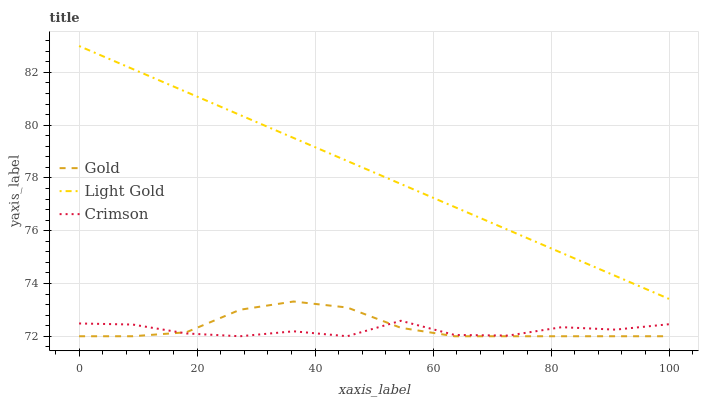Does Crimson have the minimum area under the curve?
Answer yes or no. Yes. Does Light Gold have the maximum area under the curve?
Answer yes or no. Yes. Does Gold have the minimum area under the curve?
Answer yes or no. No. Does Gold have the maximum area under the curve?
Answer yes or no. No. Is Light Gold the smoothest?
Answer yes or no. Yes. Is Crimson the roughest?
Answer yes or no. Yes. Is Gold the smoothest?
Answer yes or no. No. Is Gold the roughest?
Answer yes or no. No. Does Crimson have the lowest value?
Answer yes or no. Yes. Does Light Gold have the lowest value?
Answer yes or no. No. Does Light Gold have the highest value?
Answer yes or no. Yes. Does Gold have the highest value?
Answer yes or no. No. Is Gold less than Light Gold?
Answer yes or no. Yes. Is Light Gold greater than Gold?
Answer yes or no. Yes. Does Gold intersect Crimson?
Answer yes or no. Yes. Is Gold less than Crimson?
Answer yes or no. No. Is Gold greater than Crimson?
Answer yes or no. No. Does Gold intersect Light Gold?
Answer yes or no. No. 